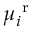<formula> <loc_0><loc_0><loc_500><loc_500>\mu _ { i } ^ { r }</formula> 